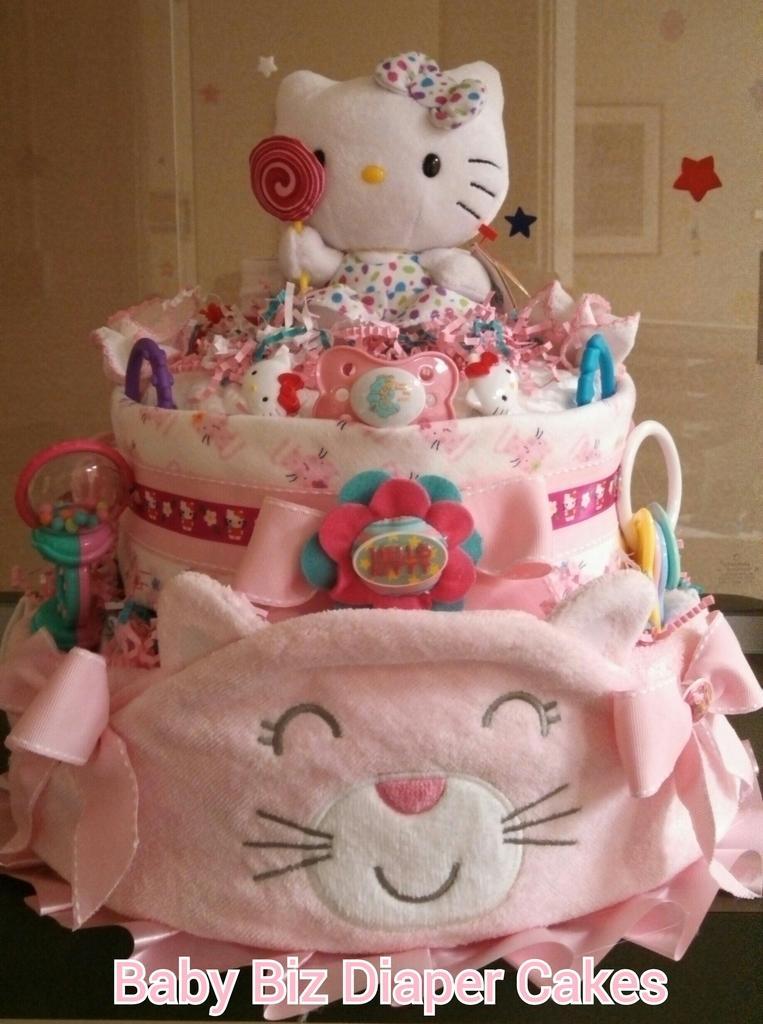In one or two sentences, can you explain what this image depicts? In this image I can see the toys. In the background, I can see a photo frame. 